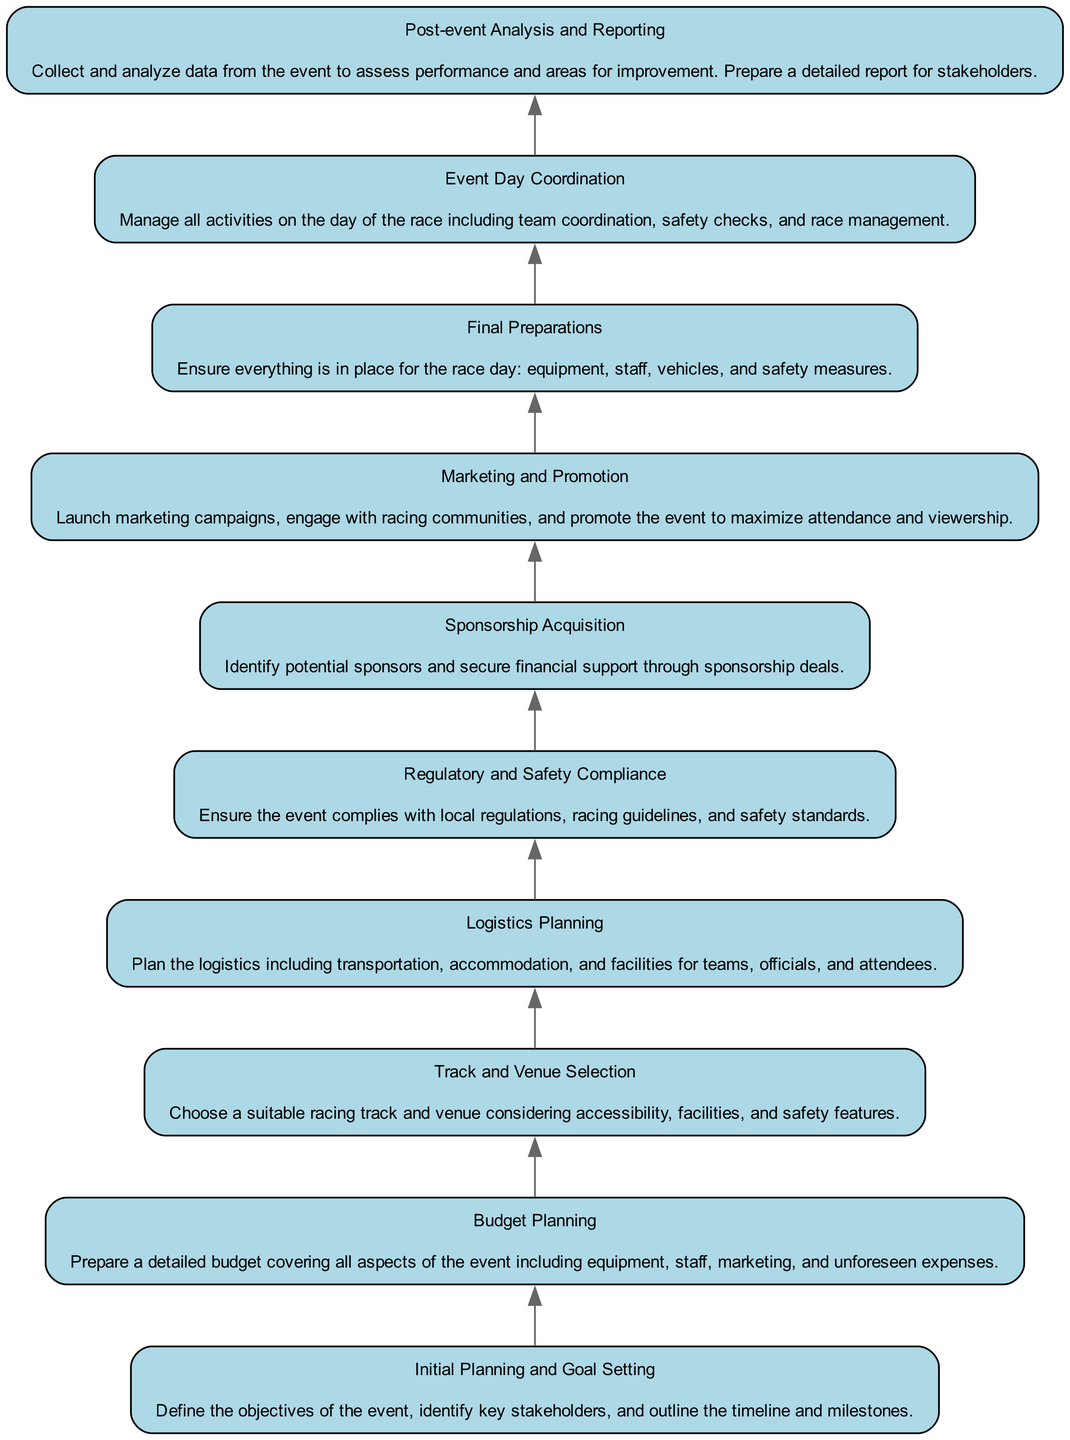What is the top node in the diagram? The top node represents the final step in the flow chart, which is "Post-event Analysis and Reporting". This is identified as the last node when reading the flow from bottom to top.
Answer: Post-event Analysis and Reporting How many total nodes are present in the diagram? By counting each unique element in the diagram, there are ten nodes listed from "Initial Planning and Goal Setting" to "Post-event Analysis and Reporting".
Answer: Ten Which node directly follows "Budget Planning"? Following the flow upward from "Budget Planning", the next node is "Track and Venue Selection", indicating a logical progression in planning.
Answer: Track and Venue Selection What is the relationship between "Marketing and Promotion" and "Sponsorship Acquisition"? "Marketing and Promotion" comes after "Sponsorship Acquisition" when following the flow upwards, suggesting sponsorship support might be sought before promoting the event.
Answer: Sponsorship Acquisition Name the node preceding "Event Day Coordination". From the flow, the node right before "Event Day Coordination" is "Final Preparations". This indicates that final preparations are essential before coordinating activities on race day.
Answer: Final Preparations What is the node that comes before "Regulatory and Safety Compliance"? "Logistics Planning" is the node that precedes "Regulatory and Safety Compliance", demonstrating the order in which logistics should be addressed before ensuring compliance.
Answer: Logistics Planning Which aspect emphasizes community engagement in the event planning process? The "Marketing and Promotion" node emphasizes community engagement, as it involves launching campaigns and connecting with racing enthusiasts to boost attendance.
Answer: Marketing and Promotion What is the purpose of the "Initial Planning and Goal Setting" node? This node defines the groundwork for the event by setting objectives, identifying stakeholders, and outlining a timeline, laying the foundation for all subsequent planning steps.
Answer: Define the objectives of the event Which two nodes are focused on compliance and safety? The nodes "Regulatory and Safety Compliance" and "Final Preparations" are both crucial for ensuring that safety measures are in place, demonstrating the importance of compliance throughout the event planning.
Answer: Regulatory and Safety Compliance; Final Preparations 